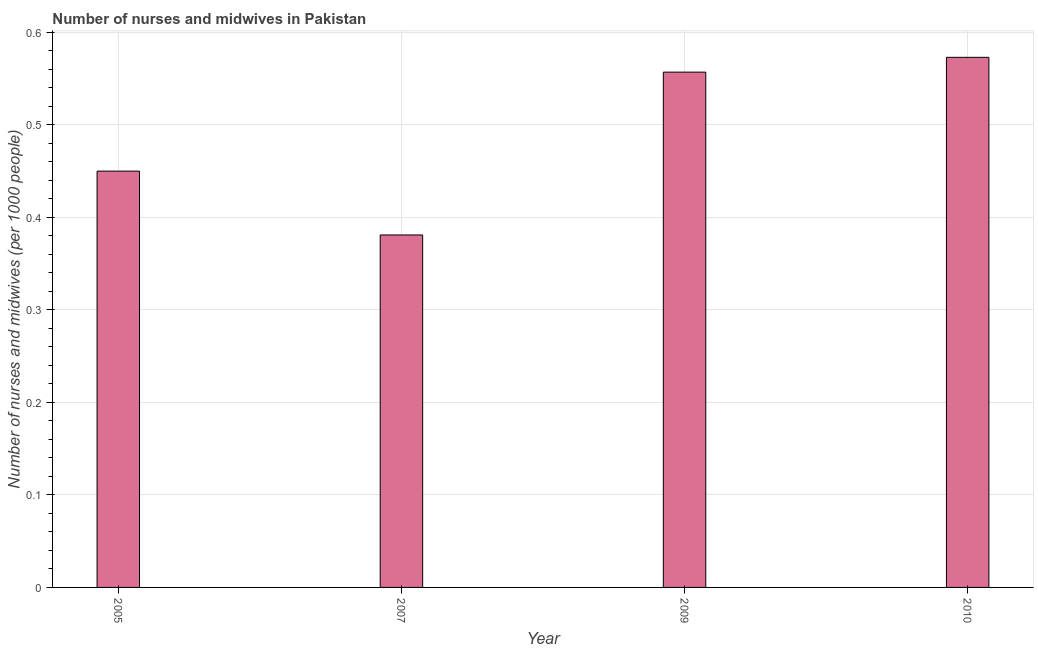Does the graph contain grids?
Offer a terse response. Yes. What is the title of the graph?
Your response must be concise. Number of nurses and midwives in Pakistan. What is the label or title of the Y-axis?
Keep it short and to the point. Number of nurses and midwives (per 1000 people). What is the number of nurses and midwives in 2009?
Ensure brevity in your answer.  0.56. Across all years, what is the maximum number of nurses and midwives?
Your answer should be very brief. 0.57. Across all years, what is the minimum number of nurses and midwives?
Give a very brief answer. 0.38. In which year was the number of nurses and midwives minimum?
Your answer should be compact. 2007. What is the sum of the number of nurses and midwives?
Provide a succinct answer. 1.96. What is the difference between the number of nurses and midwives in 2007 and 2010?
Keep it short and to the point. -0.19. What is the average number of nurses and midwives per year?
Keep it short and to the point. 0.49. What is the median number of nurses and midwives?
Give a very brief answer. 0.5. What is the ratio of the number of nurses and midwives in 2009 to that in 2010?
Ensure brevity in your answer.  0.97. What is the difference between the highest and the second highest number of nurses and midwives?
Your answer should be very brief. 0.02. Is the sum of the number of nurses and midwives in 2005 and 2009 greater than the maximum number of nurses and midwives across all years?
Provide a succinct answer. Yes. What is the difference between the highest and the lowest number of nurses and midwives?
Your response must be concise. 0.19. How many bars are there?
Provide a short and direct response. 4. How many years are there in the graph?
Your response must be concise. 4. What is the Number of nurses and midwives (per 1000 people) of 2005?
Provide a short and direct response. 0.45. What is the Number of nurses and midwives (per 1000 people) in 2007?
Your response must be concise. 0.38. What is the Number of nurses and midwives (per 1000 people) of 2009?
Give a very brief answer. 0.56. What is the Number of nurses and midwives (per 1000 people) of 2010?
Provide a succinct answer. 0.57. What is the difference between the Number of nurses and midwives (per 1000 people) in 2005 and 2007?
Provide a short and direct response. 0.07. What is the difference between the Number of nurses and midwives (per 1000 people) in 2005 and 2009?
Keep it short and to the point. -0.11. What is the difference between the Number of nurses and midwives (per 1000 people) in 2005 and 2010?
Offer a terse response. -0.12. What is the difference between the Number of nurses and midwives (per 1000 people) in 2007 and 2009?
Your response must be concise. -0.18. What is the difference between the Number of nurses and midwives (per 1000 people) in 2007 and 2010?
Give a very brief answer. -0.19. What is the difference between the Number of nurses and midwives (per 1000 people) in 2009 and 2010?
Ensure brevity in your answer.  -0.02. What is the ratio of the Number of nurses and midwives (per 1000 people) in 2005 to that in 2007?
Offer a terse response. 1.18. What is the ratio of the Number of nurses and midwives (per 1000 people) in 2005 to that in 2009?
Your answer should be compact. 0.81. What is the ratio of the Number of nurses and midwives (per 1000 people) in 2005 to that in 2010?
Ensure brevity in your answer.  0.79. What is the ratio of the Number of nurses and midwives (per 1000 people) in 2007 to that in 2009?
Keep it short and to the point. 0.68. What is the ratio of the Number of nurses and midwives (per 1000 people) in 2007 to that in 2010?
Provide a succinct answer. 0.67. 